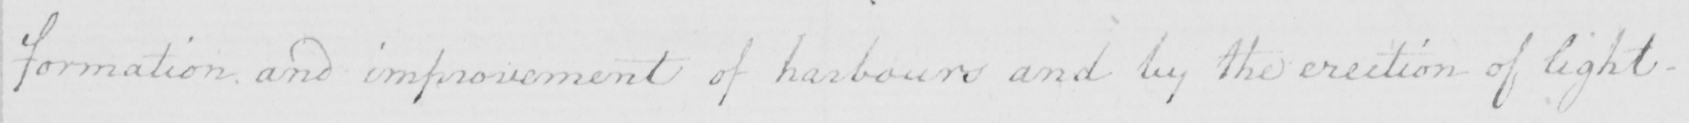Can you tell me what this handwritten text says? formation and improvement of harbours and by the erection of light- 